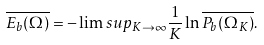Convert formula to latex. <formula><loc_0><loc_0><loc_500><loc_500>\overline { E _ { b } ( \Omega ) } = - \lim s u p _ { K \to \infty } \frac { 1 } { K } \ln \overline { P _ { b } ( \Omega _ { K } ) } .</formula> 